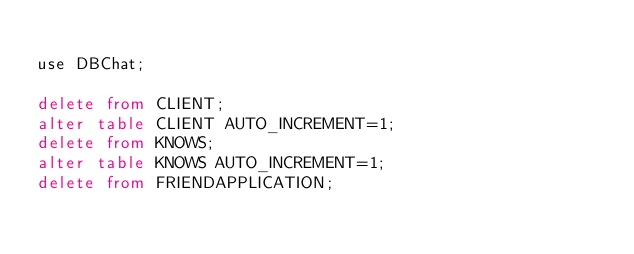<code> <loc_0><loc_0><loc_500><loc_500><_SQL_>
use DBChat;

delete from CLIENT;
alter table CLIENT AUTO_INCREMENT=1;
delete from KNOWS;
alter table KNOWS AUTO_INCREMENT=1;
delete from FRIENDAPPLICATION;</code> 